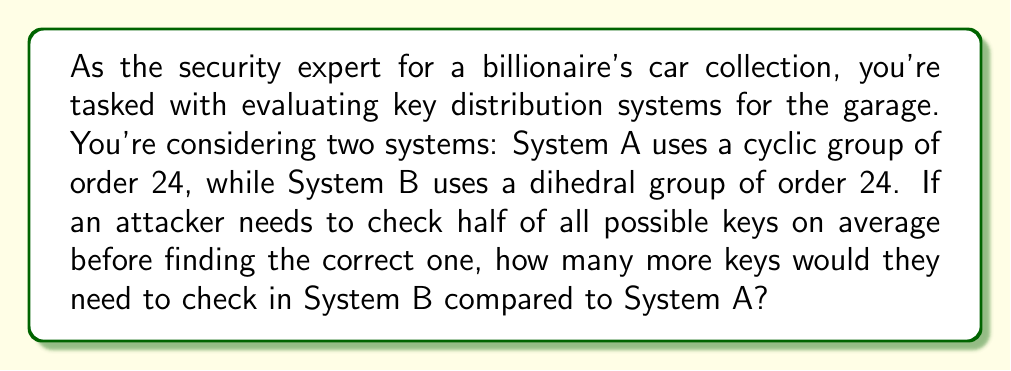Show me your answer to this math problem. To solve this problem, we need to understand the structure of cyclic and dihedral groups of order 24, and how this affects key distribution.

1) Cyclic group of order 24 (System A):
   A cyclic group of order 24 has exactly 24 elements.
   $$|C_{24}| = 24$$

2) Dihedral group of order 24 (System B):
   A dihedral group of order 24 is the symmetry group of a regular 12-gon.
   $$|D_{24}| = 24$$

3) Average number of keys to check:
   On average, an attacker would need to check half of all possible keys before finding the correct one.

   For System A: $$\frac{|C_{24}|}{2} = \frac{24}{2} = 12$$ keys

   For System B: $$\frac{|D_{24}|}{2} = \frac{24}{2} = 12$$ keys

4) Comparison:
   Both systems require checking the same number of keys on average.
   
   Difference: $$12 - 12 = 0$$ keys

Therefore, an attacker would not need to check any additional keys in System B compared to System A.

This result highlights that the order of the group alone doesn't determine the system's resistance to brute-force attacks. Other factors, such as the group's structure and how keys are generated and distributed within the group, play crucial roles in security.
Answer: 0 keys 